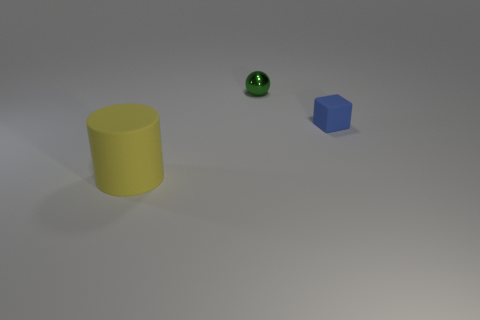Add 1 big yellow matte cylinders. How many objects exist? 4 Subtract all blocks. How many objects are left? 2 Subtract all green objects. Subtract all tiny green metal objects. How many objects are left? 1 Add 1 large rubber objects. How many large rubber objects are left? 2 Add 1 tiny green metal balls. How many tiny green metal balls exist? 2 Subtract 0 red cubes. How many objects are left? 3 